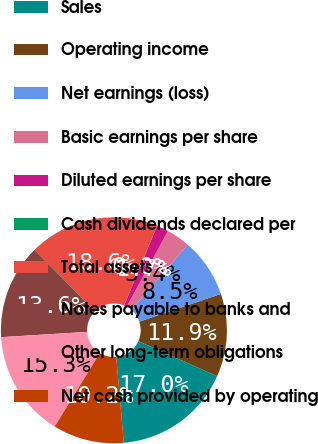Convert chart to OTSL. <chart><loc_0><loc_0><loc_500><loc_500><pie_chart><fcel>Sales<fcel>Operating income<fcel>Net earnings (loss)<fcel>Basic earnings per share<fcel>Diluted earnings per share<fcel>Cash dividends declared per<fcel>Total assets<fcel>Notes payable to banks and<fcel>Other long-term obligations<fcel>Net cash provided by operating<nl><fcel>16.95%<fcel>11.86%<fcel>8.47%<fcel>3.39%<fcel>1.7%<fcel>0.0%<fcel>18.64%<fcel>13.56%<fcel>15.25%<fcel>10.17%<nl></chart> 